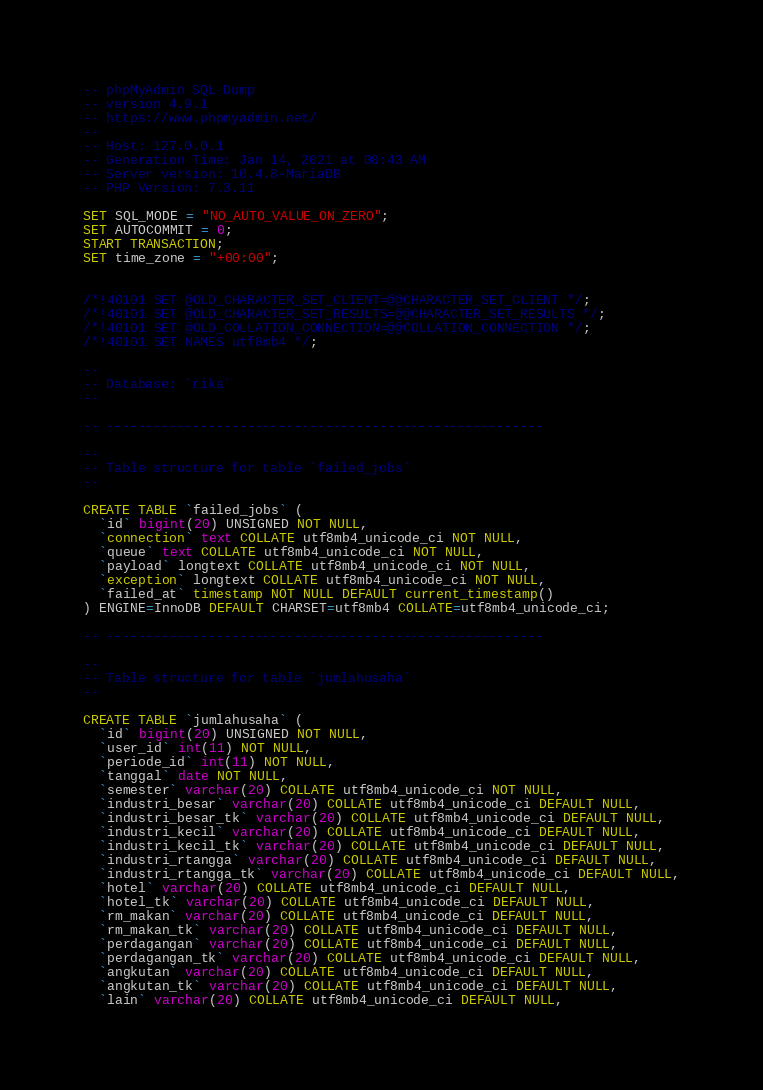Convert code to text. <code><loc_0><loc_0><loc_500><loc_500><_SQL_>-- phpMyAdmin SQL Dump
-- version 4.9.1
-- https://www.phpmyadmin.net/
--
-- Host: 127.0.0.1
-- Generation Time: Jan 14, 2021 at 08:43 AM
-- Server version: 10.4.8-MariaDB
-- PHP Version: 7.3.11

SET SQL_MODE = "NO_AUTO_VALUE_ON_ZERO";
SET AUTOCOMMIT = 0;
START TRANSACTION;
SET time_zone = "+00:00";


/*!40101 SET @OLD_CHARACTER_SET_CLIENT=@@CHARACTER_SET_CLIENT */;
/*!40101 SET @OLD_CHARACTER_SET_RESULTS=@@CHARACTER_SET_RESULTS */;
/*!40101 SET @OLD_COLLATION_CONNECTION=@@COLLATION_CONNECTION */;
/*!40101 SET NAMES utf8mb4 */;

--
-- Database: `rika`
--

-- --------------------------------------------------------

--
-- Table structure for table `failed_jobs`
--

CREATE TABLE `failed_jobs` (
  `id` bigint(20) UNSIGNED NOT NULL,
  `connection` text COLLATE utf8mb4_unicode_ci NOT NULL,
  `queue` text COLLATE utf8mb4_unicode_ci NOT NULL,
  `payload` longtext COLLATE utf8mb4_unicode_ci NOT NULL,
  `exception` longtext COLLATE utf8mb4_unicode_ci NOT NULL,
  `failed_at` timestamp NOT NULL DEFAULT current_timestamp()
) ENGINE=InnoDB DEFAULT CHARSET=utf8mb4 COLLATE=utf8mb4_unicode_ci;

-- --------------------------------------------------------

--
-- Table structure for table `jumlahusaha`
--

CREATE TABLE `jumlahusaha` (
  `id` bigint(20) UNSIGNED NOT NULL,
  `user_id` int(11) NOT NULL,
  `periode_id` int(11) NOT NULL,
  `tanggal` date NOT NULL,
  `semester` varchar(20) COLLATE utf8mb4_unicode_ci NOT NULL,
  `industri_besar` varchar(20) COLLATE utf8mb4_unicode_ci DEFAULT NULL,
  `industri_besar_tk` varchar(20) COLLATE utf8mb4_unicode_ci DEFAULT NULL,
  `industri_kecil` varchar(20) COLLATE utf8mb4_unicode_ci DEFAULT NULL,
  `industri_kecil_tk` varchar(20) COLLATE utf8mb4_unicode_ci DEFAULT NULL,
  `industri_rtangga` varchar(20) COLLATE utf8mb4_unicode_ci DEFAULT NULL,
  `industri_rtangga_tk` varchar(20) COLLATE utf8mb4_unicode_ci DEFAULT NULL,
  `hotel` varchar(20) COLLATE utf8mb4_unicode_ci DEFAULT NULL,
  `hotel_tk` varchar(20) COLLATE utf8mb4_unicode_ci DEFAULT NULL,
  `rm_makan` varchar(20) COLLATE utf8mb4_unicode_ci DEFAULT NULL,
  `rm_makan_tk` varchar(20) COLLATE utf8mb4_unicode_ci DEFAULT NULL,
  `perdagangan` varchar(20) COLLATE utf8mb4_unicode_ci DEFAULT NULL,
  `perdagangan_tk` varchar(20) COLLATE utf8mb4_unicode_ci DEFAULT NULL,
  `angkutan` varchar(20) COLLATE utf8mb4_unicode_ci DEFAULT NULL,
  `angkutan_tk` varchar(20) COLLATE utf8mb4_unicode_ci DEFAULT NULL,
  `lain` varchar(20) COLLATE utf8mb4_unicode_ci DEFAULT NULL,</code> 